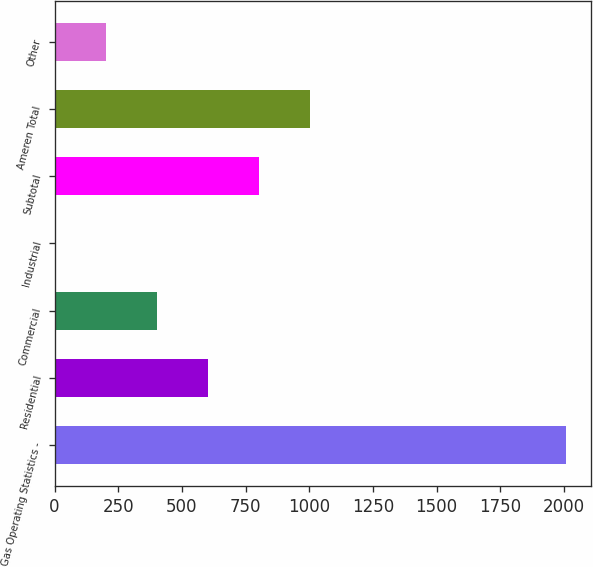Convert chart to OTSL. <chart><loc_0><loc_0><loc_500><loc_500><bar_chart><fcel>Gas Operating Statistics -<fcel>Residential<fcel>Commercial<fcel>Industrial<fcel>Subtotal<fcel>Ameren Total<fcel>Other<nl><fcel>2006<fcel>602.5<fcel>402<fcel>1<fcel>803<fcel>1003.5<fcel>201.5<nl></chart> 